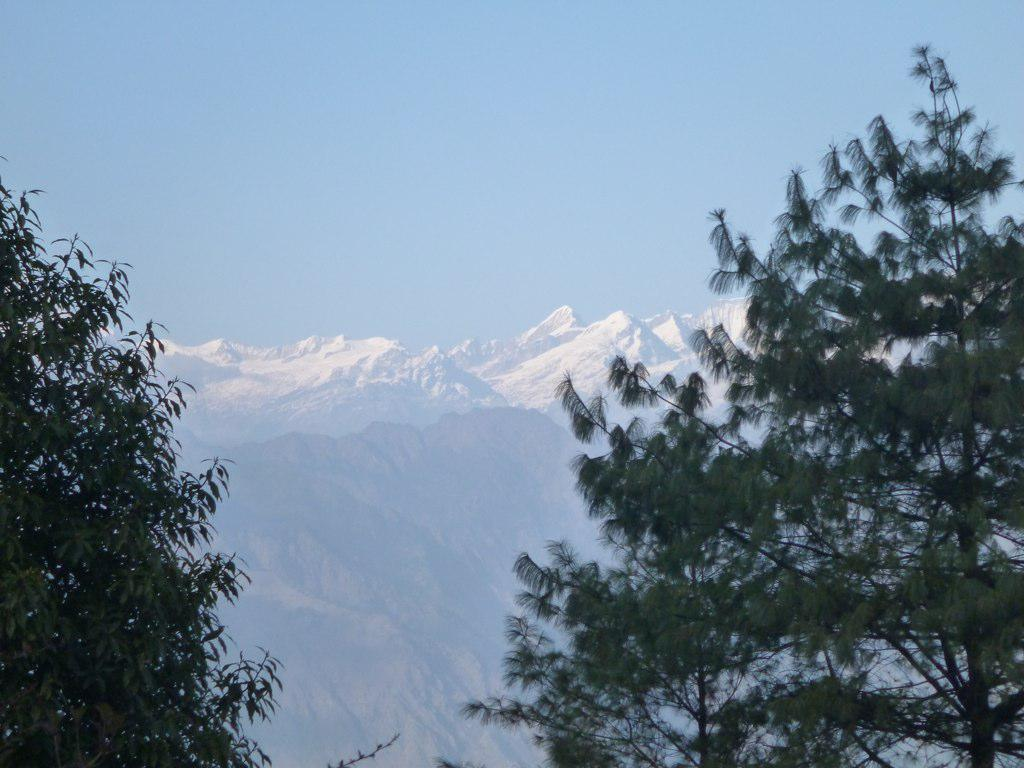What type of vegetation is visible in the front of the image? There are trees in the front of the image. What type of natural landform can be seen in the background of the image? There are mountains in the background of the image. Can you tell me how many frogs are sitting on the secretary's desk in the image? There are no frogs or secretaries present in the image; it features trees in the front and mountains in the background. 